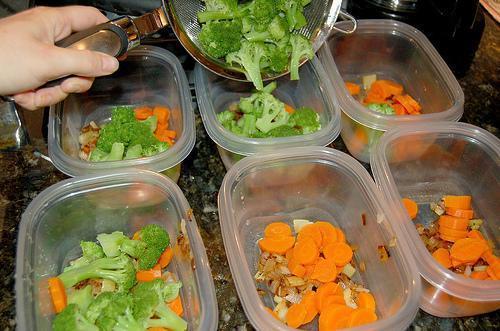How many plastic containers?
Give a very brief answer. 6. How many containers have broccoli in them?
Give a very brief answer. 4. How many bowls contain onions?
Give a very brief answer. 6. How many containers do not contain broccoli?
Give a very brief answer. 2. 